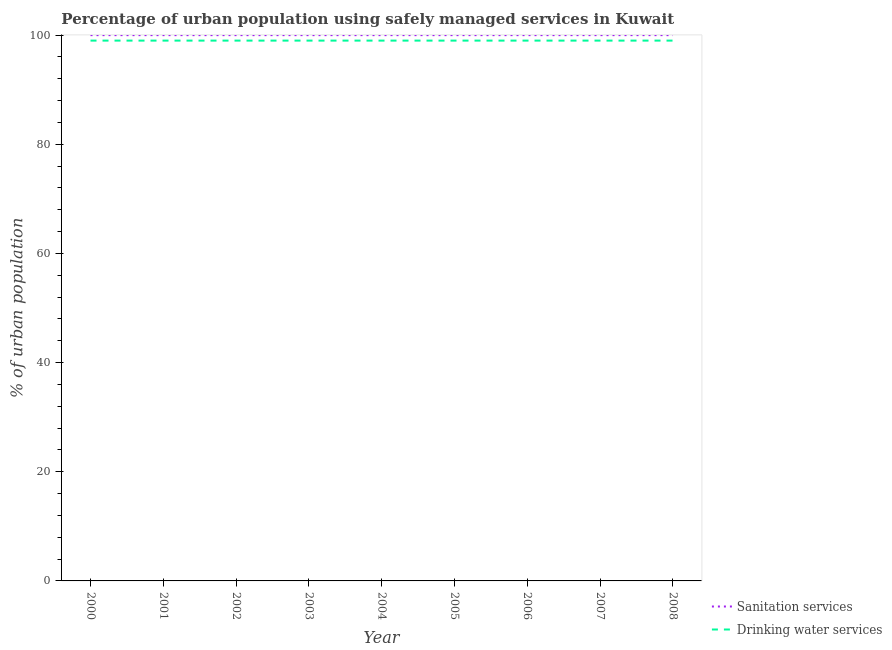Does the line corresponding to percentage of urban population who used sanitation services intersect with the line corresponding to percentage of urban population who used drinking water services?
Make the answer very short. No. What is the percentage of urban population who used drinking water services in 2007?
Make the answer very short. 99. Across all years, what is the maximum percentage of urban population who used sanitation services?
Your answer should be very brief. 100. Across all years, what is the minimum percentage of urban population who used drinking water services?
Your answer should be very brief. 99. In which year was the percentage of urban population who used sanitation services minimum?
Offer a very short reply. 2000. What is the total percentage of urban population who used sanitation services in the graph?
Keep it short and to the point. 900. What is the difference between the percentage of urban population who used drinking water services in 2002 and the percentage of urban population who used sanitation services in 2006?
Make the answer very short. -1. What is the average percentage of urban population who used drinking water services per year?
Give a very brief answer. 99. In the year 2005, what is the difference between the percentage of urban population who used sanitation services and percentage of urban population who used drinking water services?
Ensure brevity in your answer.  1. What is the ratio of the percentage of urban population who used drinking water services in 2007 to that in 2008?
Provide a short and direct response. 1. Is the percentage of urban population who used drinking water services in 2007 less than that in 2008?
Offer a terse response. No. Is the difference between the percentage of urban population who used sanitation services in 2006 and 2007 greater than the difference between the percentage of urban population who used drinking water services in 2006 and 2007?
Your answer should be compact. No. What is the difference between the highest and the second highest percentage of urban population who used drinking water services?
Your answer should be compact. 0. In how many years, is the percentage of urban population who used drinking water services greater than the average percentage of urban population who used drinking water services taken over all years?
Your response must be concise. 0. Does the percentage of urban population who used sanitation services monotonically increase over the years?
Offer a very short reply. No. Is the percentage of urban population who used sanitation services strictly less than the percentage of urban population who used drinking water services over the years?
Ensure brevity in your answer.  No. How many lines are there?
Your answer should be very brief. 2. What is the difference between two consecutive major ticks on the Y-axis?
Ensure brevity in your answer.  20. Does the graph contain grids?
Make the answer very short. No. Where does the legend appear in the graph?
Offer a very short reply. Bottom right. How many legend labels are there?
Your answer should be very brief. 2. How are the legend labels stacked?
Your answer should be compact. Vertical. What is the title of the graph?
Provide a succinct answer. Percentage of urban population using safely managed services in Kuwait. Does "International Tourists" appear as one of the legend labels in the graph?
Offer a very short reply. No. What is the label or title of the X-axis?
Your answer should be compact. Year. What is the label or title of the Y-axis?
Give a very brief answer. % of urban population. What is the % of urban population of Sanitation services in 2000?
Provide a succinct answer. 100. What is the % of urban population in Sanitation services in 2001?
Offer a very short reply. 100. What is the % of urban population of Drinking water services in 2001?
Keep it short and to the point. 99. What is the % of urban population in Drinking water services in 2002?
Your answer should be very brief. 99. What is the % of urban population of Sanitation services in 2003?
Offer a very short reply. 100. What is the % of urban population of Drinking water services in 2004?
Offer a terse response. 99. What is the % of urban population in Sanitation services in 2005?
Offer a terse response. 100. What is the % of urban population in Sanitation services in 2006?
Your answer should be compact. 100. What is the % of urban population in Drinking water services in 2006?
Offer a terse response. 99. What is the % of urban population of Sanitation services in 2007?
Keep it short and to the point. 100. What is the % of urban population in Drinking water services in 2007?
Provide a succinct answer. 99. What is the % of urban population of Drinking water services in 2008?
Keep it short and to the point. 99. Across all years, what is the minimum % of urban population of Sanitation services?
Ensure brevity in your answer.  100. What is the total % of urban population of Sanitation services in the graph?
Your answer should be very brief. 900. What is the total % of urban population in Drinking water services in the graph?
Your response must be concise. 891. What is the difference between the % of urban population of Sanitation services in 2000 and that in 2001?
Your response must be concise. 0. What is the difference between the % of urban population of Drinking water services in 2000 and that in 2001?
Your answer should be compact. 0. What is the difference between the % of urban population in Sanitation services in 2000 and that in 2002?
Provide a succinct answer. 0. What is the difference between the % of urban population of Drinking water services in 2000 and that in 2004?
Your answer should be compact. 0. What is the difference between the % of urban population of Drinking water services in 2000 and that in 2005?
Ensure brevity in your answer.  0. What is the difference between the % of urban population in Sanitation services in 2000 and that in 2006?
Keep it short and to the point. 0. What is the difference between the % of urban population in Drinking water services in 2000 and that in 2006?
Your answer should be compact. 0. What is the difference between the % of urban population in Sanitation services in 2000 and that in 2007?
Provide a succinct answer. 0. What is the difference between the % of urban population in Drinking water services in 2000 and that in 2007?
Your answer should be compact. 0. What is the difference between the % of urban population in Sanitation services in 2000 and that in 2008?
Keep it short and to the point. 0. What is the difference between the % of urban population of Sanitation services in 2001 and that in 2002?
Make the answer very short. 0. What is the difference between the % of urban population in Sanitation services in 2001 and that in 2004?
Provide a succinct answer. 0. What is the difference between the % of urban population in Drinking water services in 2001 and that in 2005?
Provide a succinct answer. 0. What is the difference between the % of urban population of Drinking water services in 2001 and that in 2008?
Your response must be concise. 0. What is the difference between the % of urban population in Sanitation services in 2002 and that in 2003?
Make the answer very short. 0. What is the difference between the % of urban population of Drinking water services in 2002 and that in 2003?
Keep it short and to the point. 0. What is the difference between the % of urban population of Sanitation services in 2002 and that in 2004?
Your answer should be very brief. 0. What is the difference between the % of urban population in Sanitation services in 2002 and that in 2005?
Provide a succinct answer. 0. What is the difference between the % of urban population in Drinking water services in 2002 and that in 2005?
Give a very brief answer. 0. What is the difference between the % of urban population of Drinking water services in 2002 and that in 2007?
Keep it short and to the point. 0. What is the difference between the % of urban population of Sanitation services in 2002 and that in 2008?
Offer a very short reply. 0. What is the difference between the % of urban population of Drinking water services in 2002 and that in 2008?
Make the answer very short. 0. What is the difference between the % of urban population of Sanitation services in 2003 and that in 2004?
Provide a short and direct response. 0. What is the difference between the % of urban population in Drinking water services in 2003 and that in 2004?
Your response must be concise. 0. What is the difference between the % of urban population in Drinking water services in 2003 and that in 2005?
Offer a very short reply. 0. What is the difference between the % of urban population in Drinking water services in 2003 and that in 2007?
Give a very brief answer. 0. What is the difference between the % of urban population of Sanitation services in 2004 and that in 2005?
Your response must be concise. 0. What is the difference between the % of urban population in Sanitation services in 2004 and that in 2006?
Offer a very short reply. 0. What is the difference between the % of urban population of Drinking water services in 2004 and that in 2006?
Ensure brevity in your answer.  0. What is the difference between the % of urban population in Sanitation services in 2004 and that in 2008?
Your answer should be very brief. 0. What is the difference between the % of urban population in Sanitation services in 2005 and that in 2006?
Offer a very short reply. 0. What is the difference between the % of urban population in Drinking water services in 2005 and that in 2007?
Give a very brief answer. 0. What is the difference between the % of urban population of Sanitation services in 2006 and that in 2007?
Provide a succinct answer. 0. What is the difference between the % of urban population of Sanitation services in 2006 and that in 2008?
Keep it short and to the point. 0. What is the difference between the % of urban population of Sanitation services in 2000 and the % of urban population of Drinking water services in 2001?
Provide a succinct answer. 1. What is the difference between the % of urban population in Sanitation services in 2000 and the % of urban population in Drinking water services in 2002?
Offer a terse response. 1. What is the difference between the % of urban population of Sanitation services in 2000 and the % of urban population of Drinking water services in 2006?
Your response must be concise. 1. What is the difference between the % of urban population of Sanitation services in 2000 and the % of urban population of Drinking water services in 2007?
Offer a terse response. 1. What is the difference between the % of urban population of Sanitation services in 2000 and the % of urban population of Drinking water services in 2008?
Keep it short and to the point. 1. What is the difference between the % of urban population in Sanitation services in 2001 and the % of urban population in Drinking water services in 2002?
Your answer should be very brief. 1. What is the difference between the % of urban population in Sanitation services in 2001 and the % of urban population in Drinking water services in 2003?
Your answer should be very brief. 1. What is the difference between the % of urban population in Sanitation services in 2001 and the % of urban population in Drinking water services in 2004?
Your answer should be very brief. 1. What is the difference between the % of urban population of Sanitation services in 2001 and the % of urban population of Drinking water services in 2005?
Your response must be concise. 1. What is the difference between the % of urban population in Sanitation services in 2001 and the % of urban population in Drinking water services in 2006?
Provide a succinct answer. 1. What is the difference between the % of urban population of Sanitation services in 2001 and the % of urban population of Drinking water services in 2007?
Your answer should be very brief. 1. What is the difference between the % of urban population in Sanitation services in 2001 and the % of urban population in Drinking water services in 2008?
Provide a short and direct response. 1. What is the difference between the % of urban population in Sanitation services in 2002 and the % of urban population in Drinking water services in 2004?
Your answer should be compact. 1. What is the difference between the % of urban population of Sanitation services in 2002 and the % of urban population of Drinking water services in 2007?
Provide a short and direct response. 1. What is the difference between the % of urban population in Sanitation services in 2002 and the % of urban population in Drinking water services in 2008?
Your response must be concise. 1. What is the difference between the % of urban population of Sanitation services in 2003 and the % of urban population of Drinking water services in 2004?
Ensure brevity in your answer.  1. What is the difference between the % of urban population in Sanitation services in 2003 and the % of urban population in Drinking water services in 2005?
Provide a short and direct response. 1. What is the difference between the % of urban population in Sanitation services in 2003 and the % of urban population in Drinking water services in 2007?
Your answer should be very brief. 1. What is the difference between the % of urban population of Sanitation services in 2004 and the % of urban population of Drinking water services in 2008?
Your answer should be compact. 1. What is the difference between the % of urban population in Sanitation services in 2005 and the % of urban population in Drinking water services in 2006?
Your response must be concise. 1. What is the difference between the % of urban population in Sanitation services in 2005 and the % of urban population in Drinking water services in 2008?
Offer a very short reply. 1. What is the difference between the % of urban population in Sanitation services in 2006 and the % of urban population in Drinking water services in 2007?
Make the answer very short. 1. What is the difference between the % of urban population in Sanitation services in 2006 and the % of urban population in Drinking water services in 2008?
Your response must be concise. 1. What is the average % of urban population of Sanitation services per year?
Ensure brevity in your answer.  100. What is the average % of urban population of Drinking water services per year?
Your answer should be very brief. 99. In the year 2003, what is the difference between the % of urban population in Sanitation services and % of urban population in Drinking water services?
Make the answer very short. 1. In the year 2005, what is the difference between the % of urban population of Sanitation services and % of urban population of Drinking water services?
Ensure brevity in your answer.  1. In the year 2007, what is the difference between the % of urban population of Sanitation services and % of urban population of Drinking water services?
Your response must be concise. 1. In the year 2008, what is the difference between the % of urban population of Sanitation services and % of urban population of Drinking water services?
Offer a very short reply. 1. What is the ratio of the % of urban population in Drinking water services in 2000 to that in 2002?
Your answer should be very brief. 1. What is the ratio of the % of urban population of Sanitation services in 2000 to that in 2004?
Keep it short and to the point. 1. What is the ratio of the % of urban population in Drinking water services in 2000 to that in 2004?
Your answer should be very brief. 1. What is the ratio of the % of urban population of Sanitation services in 2000 to that in 2005?
Provide a short and direct response. 1. What is the ratio of the % of urban population in Drinking water services in 2000 to that in 2005?
Provide a short and direct response. 1. What is the ratio of the % of urban population in Drinking water services in 2000 to that in 2006?
Your answer should be very brief. 1. What is the ratio of the % of urban population of Drinking water services in 2000 to that in 2007?
Ensure brevity in your answer.  1. What is the ratio of the % of urban population in Sanitation services in 2000 to that in 2008?
Provide a short and direct response. 1. What is the ratio of the % of urban population in Drinking water services in 2000 to that in 2008?
Keep it short and to the point. 1. What is the ratio of the % of urban population of Drinking water services in 2001 to that in 2002?
Keep it short and to the point. 1. What is the ratio of the % of urban population in Drinking water services in 2001 to that in 2003?
Make the answer very short. 1. What is the ratio of the % of urban population in Sanitation services in 2001 to that in 2005?
Make the answer very short. 1. What is the ratio of the % of urban population of Sanitation services in 2001 to that in 2007?
Give a very brief answer. 1. What is the ratio of the % of urban population in Sanitation services in 2001 to that in 2008?
Your response must be concise. 1. What is the ratio of the % of urban population in Sanitation services in 2002 to that in 2003?
Your answer should be compact. 1. What is the ratio of the % of urban population in Drinking water services in 2002 to that in 2005?
Your answer should be compact. 1. What is the ratio of the % of urban population of Drinking water services in 2002 to that in 2006?
Give a very brief answer. 1. What is the ratio of the % of urban population of Sanitation services in 2002 to that in 2007?
Your answer should be very brief. 1. What is the ratio of the % of urban population of Drinking water services in 2002 to that in 2008?
Provide a succinct answer. 1. What is the ratio of the % of urban population in Drinking water services in 2003 to that in 2004?
Give a very brief answer. 1. What is the ratio of the % of urban population in Sanitation services in 2003 to that in 2006?
Provide a short and direct response. 1. What is the ratio of the % of urban population of Drinking water services in 2003 to that in 2006?
Provide a short and direct response. 1. What is the ratio of the % of urban population in Sanitation services in 2003 to that in 2007?
Make the answer very short. 1. What is the ratio of the % of urban population in Drinking water services in 2003 to that in 2007?
Offer a terse response. 1. What is the ratio of the % of urban population of Drinking water services in 2003 to that in 2008?
Keep it short and to the point. 1. What is the ratio of the % of urban population in Sanitation services in 2004 to that in 2005?
Make the answer very short. 1. What is the ratio of the % of urban population of Drinking water services in 2004 to that in 2005?
Keep it short and to the point. 1. What is the ratio of the % of urban population of Sanitation services in 2004 to that in 2006?
Your response must be concise. 1. What is the ratio of the % of urban population of Sanitation services in 2004 to that in 2007?
Make the answer very short. 1. What is the ratio of the % of urban population in Sanitation services in 2004 to that in 2008?
Provide a short and direct response. 1. What is the ratio of the % of urban population in Drinking water services in 2004 to that in 2008?
Make the answer very short. 1. What is the ratio of the % of urban population of Sanitation services in 2005 to that in 2006?
Ensure brevity in your answer.  1. What is the ratio of the % of urban population in Drinking water services in 2005 to that in 2007?
Your answer should be compact. 1. What is the ratio of the % of urban population in Sanitation services in 2005 to that in 2008?
Provide a short and direct response. 1. What is the ratio of the % of urban population in Sanitation services in 2006 to that in 2008?
Your answer should be very brief. 1. What is the ratio of the % of urban population of Drinking water services in 2006 to that in 2008?
Give a very brief answer. 1. What is the ratio of the % of urban population in Sanitation services in 2007 to that in 2008?
Provide a short and direct response. 1. What is the ratio of the % of urban population in Drinking water services in 2007 to that in 2008?
Keep it short and to the point. 1. What is the difference between the highest and the second highest % of urban population of Drinking water services?
Ensure brevity in your answer.  0. What is the difference between the highest and the lowest % of urban population in Drinking water services?
Your response must be concise. 0. 